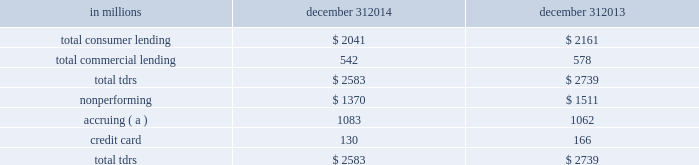Troubled debt restructurings ( tdrs ) a tdr is a loan whose terms have been restructured in a manner that grants a concession to a borrower experiencing financial difficulty .
Tdrs result from our loss mitigation activities , and include rate reductions , principal forgiveness , postponement/reduction of scheduled amortization , and extensions , which are intended to minimize economic loss and to avoid foreclosure or repossession of collateral .
Additionally , tdrs also result from borrowers that have been discharged from personal liability through chapter 7 bankruptcy and have not formally reaffirmed their loan obligations to pnc .
In those situations where principal is forgiven , the amount of such principal forgiveness is immediately charged off .
Some tdrs may not ultimately result in the full collection of principal and interest , as restructured , and result in potential incremental losses .
These potential incremental losses have been factored into our overall alll estimate .
The level of any subsequent defaults will likely be affected by future economic conditions .
Once a loan becomes a tdr , it will continue to be reported as a tdr until it is ultimately repaid in full , the collateral is foreclosed upon , or it is fully charged off .
We held specific reserves in the alll of $ .4 billion and $ .5 billion at december 31 , 2014 and december 31 , 2013 , respectively , for the total tdr portfolio .
Table 67 : summary of troubled debt restructurings in millions december 31 december 31 .
( a ) accruing tdr loans have demonstrated a period of at least six months of performance under the restructured terms and are excluded from nonperforming loans .
Loans where borrowers have been discharged from personal liability through chapter 7 bankruptcy and have not formally reaffirmed their loan obligations to pnc and loans to borrowers not currently obligated to make both principal and interest payments under the restructured terms are not returned to accrual status .
Table 68 quantifies the number of loans that were classified as tdrs as well as the change in the recorded investments as a result of the tdr classification during 2014 , 2013 , and 2012 , respectively .
Additionally , the table provides information about the types of tdr concessions .
The principal forgiveness tdr category includes principal forgiveness and accrued interest forgiveness .
These types of tdrs result in a write down of the recorded investment and a charge-off if such action has not already taken place .
The rate reduction tdr category includes reduced interest rate and interest deferral .
The tdrs within this category result in reductions to future interest income .
The other tdr category primarily includes consumer borrowers that have been discharged from personal liability through chapter 7 bankruptcy and have not formally reaffirmed their loan obligations to pnc , as well as postponement/reduction of scheduled amortization and contractual extensions for both consumer and commercial borrowers .
In some cases , there have been multiple concessions granted on one loan .
This is most common within the commercial loan portfolio .
When there have been multiple concessions granted in the commercial loan portfolio , the principal forgiveness concession was prioritized for purposes of determining the inclusion in table 68 .
For example , if there is principal forgiveness in conjunction with lower interest rate and postponement of amortization , the type of concession will be reported as principal forgiveness .
Second in priority would be rate reduction .
For example , if there is an interest rate reduction in conjunction with postponement of amortization , the type of concession will be reported as a rate reduction .
In the event that multiple concessions are granted on a consumer loan , concessions resulting from discharge from personal liability through chapter 7 bankruptcy without formal affirmation of the loan obligations to pnc would be prioritized and included in the other type of concession in the table below .
After that , consumer loan concessions would follow the previously discussed priority of concessions for the commercial loan portfolio .
138 the pnc financial services group , inc .
2013 form 10-k .
What were total specific reserves in the alll in billions at december 31 , 2014 and december 31 , 2013 for the total tdr portfolio? 
Computations: (.5 + .4)
Answer: 0.9. 